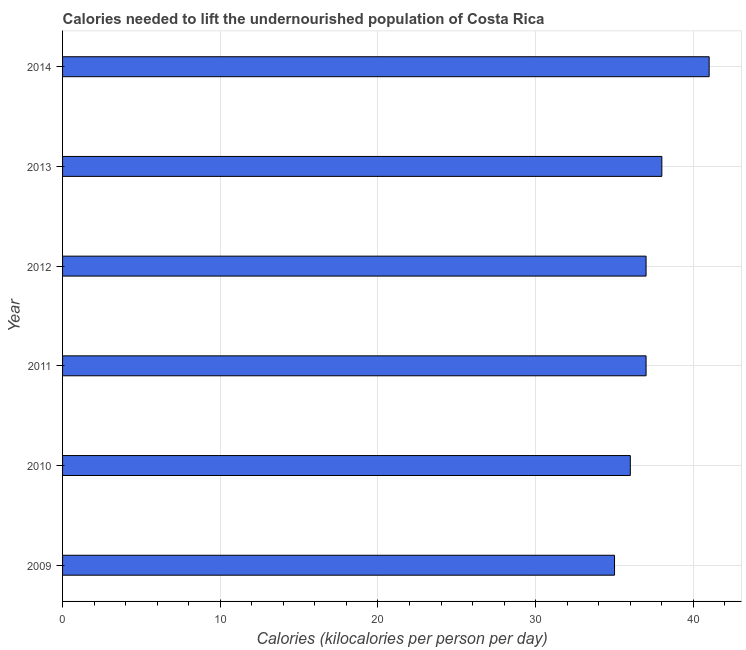Does the graph contain any zero values?
Ensure brevity in your answer.  No. What is the title of the graph?
Make the answer very short. Calories needed to lift the undernourished population of Costa Rica. What is the label or title of the X-axis?
Provide a short and direct response. Calories (kilocalories per person per day). What is the label or title of the Y-axis?
Provide a short and direct response. Year. Across all years, what is the maximum depth of food deficit?
Your answer should be compact. 41. Across all years, what is the minimum depth of food deficit?
Your answer should be compact. 35. In which year was the depth of food deficit maximum?
Your response must be concise. 2014. What is the sum of the depth of food deficit?
Your answer should be very brief. 224. In how many years, is the depth of food deficit greater than 28 kilocalories?
Offer a terse response. 6. What is the ratio of the depth of food deficit in 2009 to that in 2010?
Offer a terse response. 0.97. Is the difference between the depth of food deficit in 2009 and 2013 greater than the difference between any two years?
Make the answer very short. No. What is the Calories (kilocalories per person per day) in 2009?
Ensure brevity in your answer.  35. What is the Calories (kilocalories per person per day) of 2011?
Your answer should be compact. 37. What is the Calories (kilocalories per person per day) of 2012?
Offer a very short reply. 37. What is the Calories (kilocalories per person per day) of 2013?
Give a very brief answer. 38. What is the Calories (kilocalories per person per day) of 2014?
Offer a terse response. 41. What is the difference between the Calories (kilocalories per person per day) in 2009 and 2010?
Give a very brief answer. -1. What is the difference between the Calories (kilocalories per person per day) in 2009 and 2013?
Offer a terse response. -3. What is the difference between the Calories (kilocalories per person per day) in 2009 and 2014?
Make the answer very short. -6. What is the difference between the Calories (kilocalories per person per day) in 2010 and 2013?
Ensure brevity in your answer.  -2. What is the difference between the Calories (kilocalories per person per day) in 2013 and 2014?
Ensure brevity in your answer.  -3. What is the ratio of the Calories (kilocalories per person per day) in 2009 to that in 2011?
Offer a very short reply. 0.95. What is the ratio of the Calories (kilocalories per person per day) in 2009 to that in 2012?
Your response must be concise. 0.95. What is the ratio of the Calories (kilocalories per person per day) in 2009 to that in 2013?
Provide a succinct answer. 0.92. What is the ratio of the Calories (kilocalories per person per day) in 2009 to that in 2014?
Provide a short and direct response. 0.85. What is the ratio of the Calories (kilocalories per person per day) in 2010 to that in 2011?
Offer a terse response. 0.97. What is the ratio of the Calories (kilocalories per person per day) in 2010 to that in 2013?
Provide a short and direct response. 0.95. What is the ratio of the Calories (kilocalories per person per day) in 2010 to that in 2014?
Give a very brief answer. 0.88. What is the ratio of the Calories (kilocalories per person per day) in 2011 to that in 2013?
Keep it short and to the point. 0.97. What is the ratio of the Calories (kilocalories per person per day) in 2011 to that in 2014?
Your answer should be very brief. 0.9. What is the ratio of the Calories (kilocalories per person per day) in 2012 to that in 2014?
Give a very brief answer. 0.9. What is the ratio of the Calories (kilocalories per person per day) in 2013 to that in 2014?
Give a very brief answer. 0.93. 